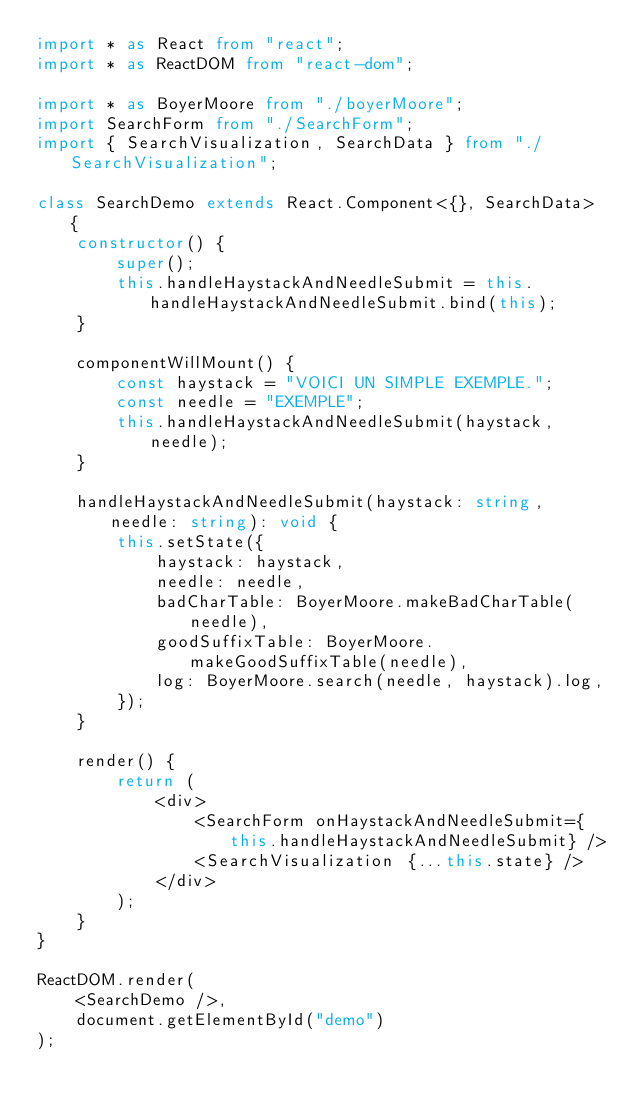Convert code to text. <code><loc_0><loc_0><loc_500><loc_500><_TypeScript_>import * as React from "react";
import * as ReactDOM from "react-dom";

import * as BoyerMoore from "./boyerMoore";
import SearchForm from "./SearchForm";
import { SearchVisualization, SearchData } from "./SearchVisualization";

class SearchDemo extends React.Component<{}, SearchData> {
    constructor() {
        super();
        this.handleHaystackAndNeedleSubmit = this.handleHaystackAndNeedleSubmit.bind(this);
    }

    componentWillMount() {
        const haystack = "VOICI UN SIMPLE EXEMPLE.";
        const needle = "EXEMPLE";
        this.handleHaystackAndNeedleSubmit(haystack, needle);
    }

    handleHaystackAndNeedleSubmit(haystack: string, needle: string): void {
        this.setState({
            haystack: haystack,
            needle: needle,
            badCharTable: BoyerMoore.makeBadCharTable(needle),
            goodSuffixTable: BoyerMoore.makeGoodSuffixTable(needle),
            log: BoyerMoore.search(needle, haystack).log,
        });
    }

    render() {
        return (
            <div>
                <SearchForm onHaystackAndNeedleSubmit={this.handleHaystackAndNeedleSubmit} />
                <SearchVisualization {...this.state} />
            </div>
        );
    }
}

ReactDOM.render(
    <SearchDemo />,
    document.getElementById("demo")
);
</code> 